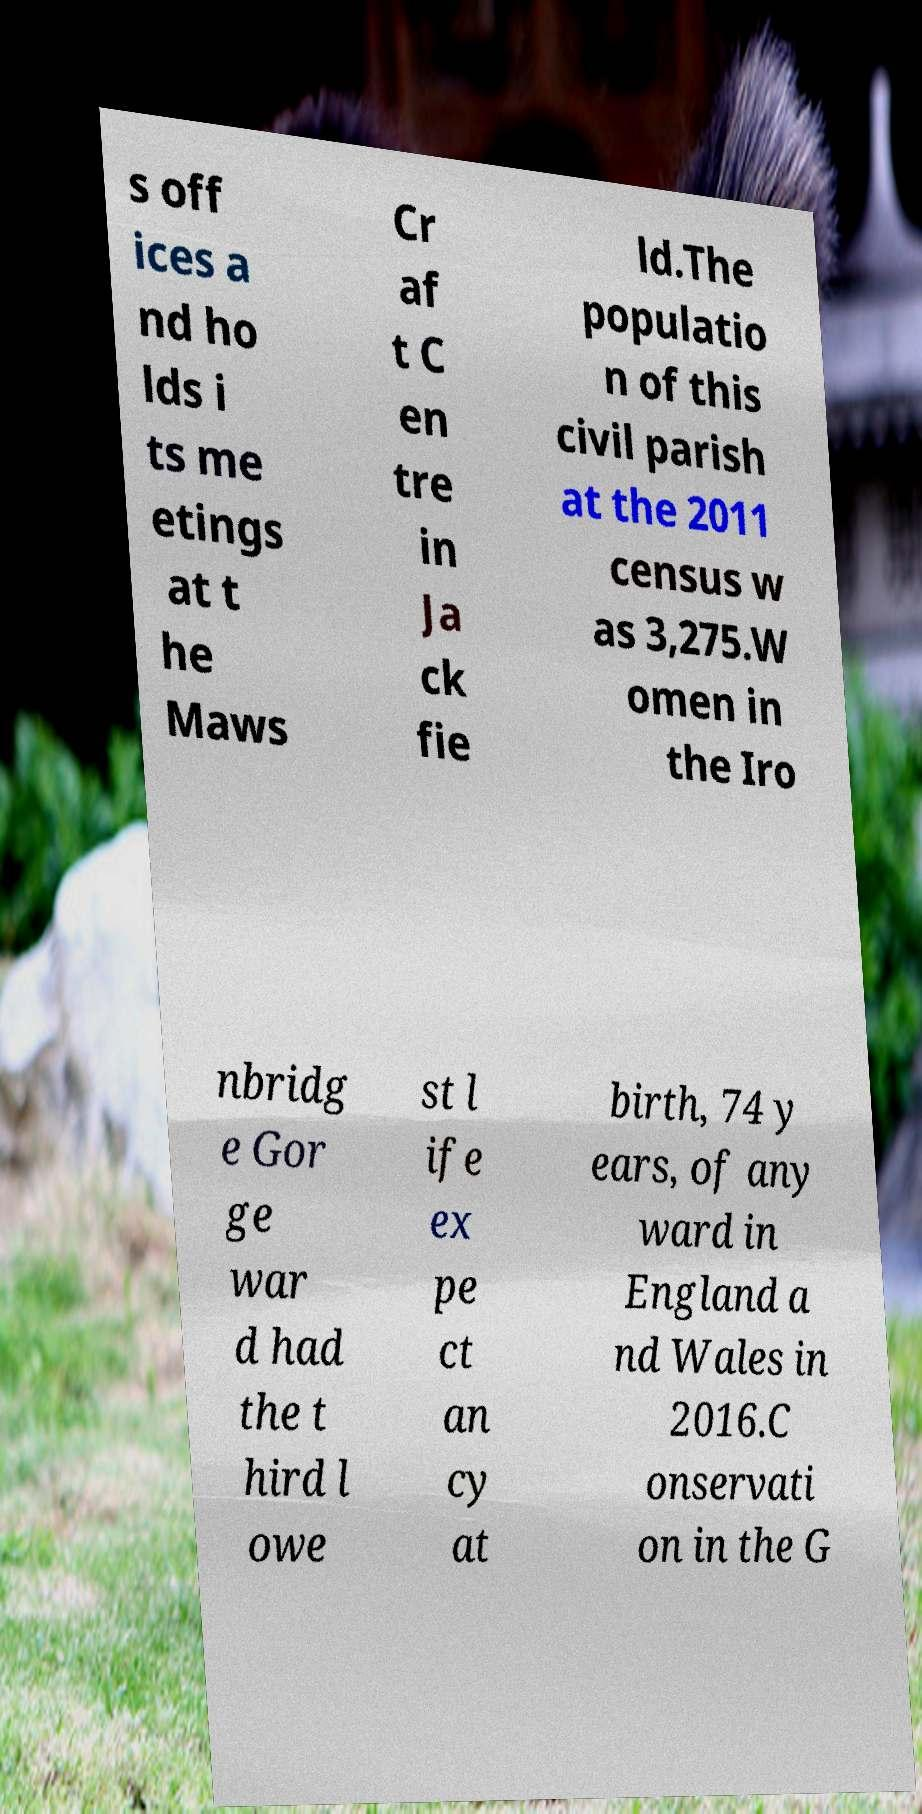Could you assist in decoding the text presented in this image and type it out clearly? s off ices a nd ho lds i ts me etings at t he Maws Cr af t C en tre in Ja ck fie ld.The populatio n of this civil parish at the 2011 census w as 3,275.W omen in the Iro nbridg e Gor ge war d had the t hird l owe st l ife ex pe ct an cy at birth, 74 y ears, of any ward in England a nd Wales in 2016.C onservati on in the G 